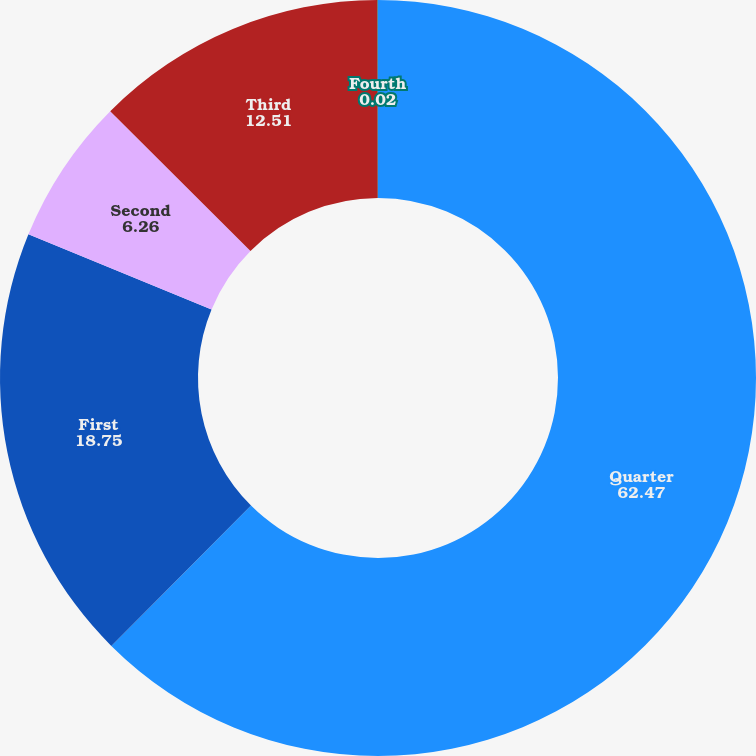Convert chart. <chart><loc_0><loc_0><loc_500><loc_500><pie_chart><fcel>Quarter<fcel>First<fcel>Second<fcel>Third<fcel>Fourth<nl><fcel>62.47%<fcel>18.75%<fcel>6.26%<fcel>12.51%<fcel>0.02%<nl></chart> 